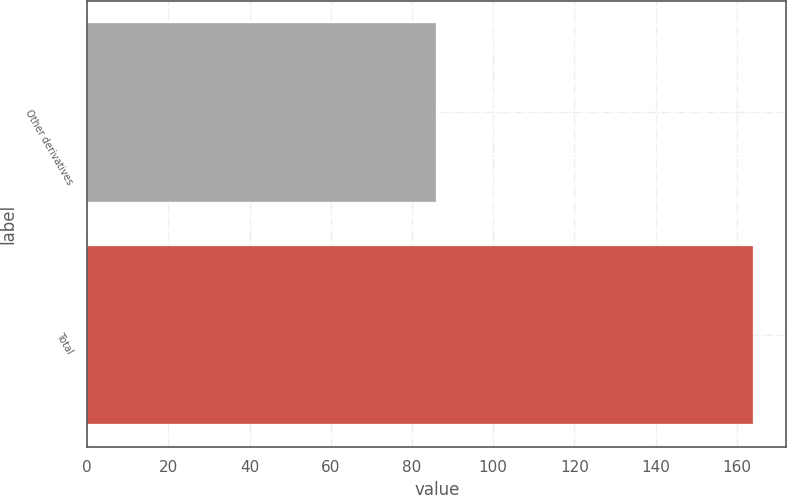Convert chart. <chart><loc_0><loc_0><loc_500><loc_500><bar_chart><fcel>Other derivatives<fcel>Total<nl><fcel>86<fcel>164<nl></chart> 